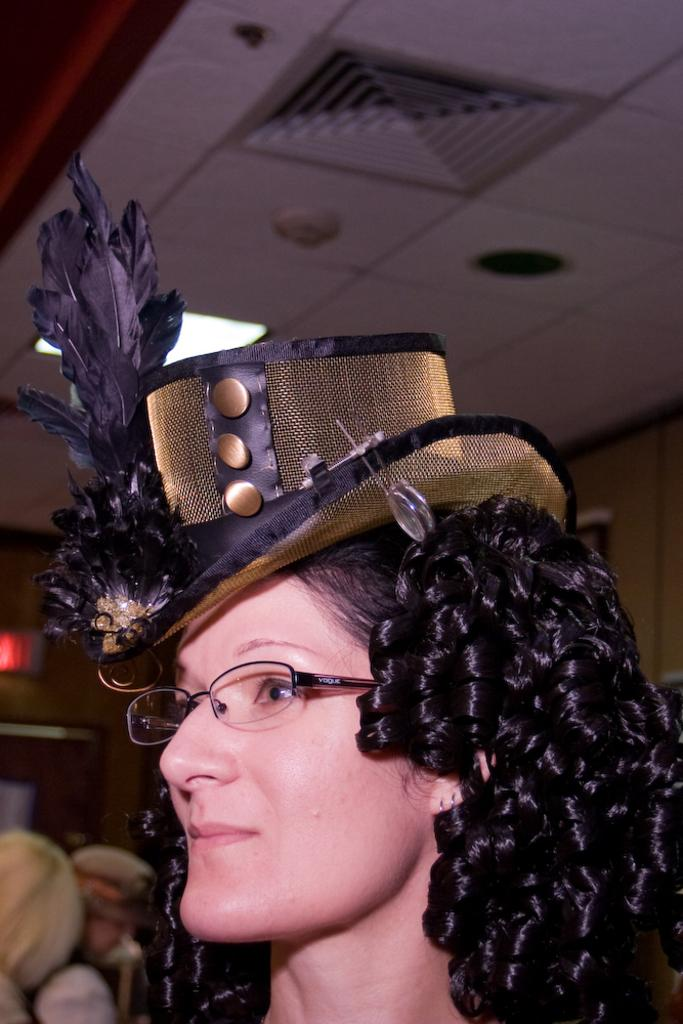Who is the main subject in the picture? There is a woman in the picture. Can you describe the woman's hair? The woman has curly hair. What is the woman wearing on her head? The woman is wearing a hat. What decorative elements are on the hat? There are feathers on the hat. How is the background of the woman depicted in the image? The background of the woman is blurred. How many sisters are depicted in the image? There is no mention of sisters in the image, as it only features a woman. What type of creature is interacting with the woman in the image? There is no creature present in the image; it only features the woman. 